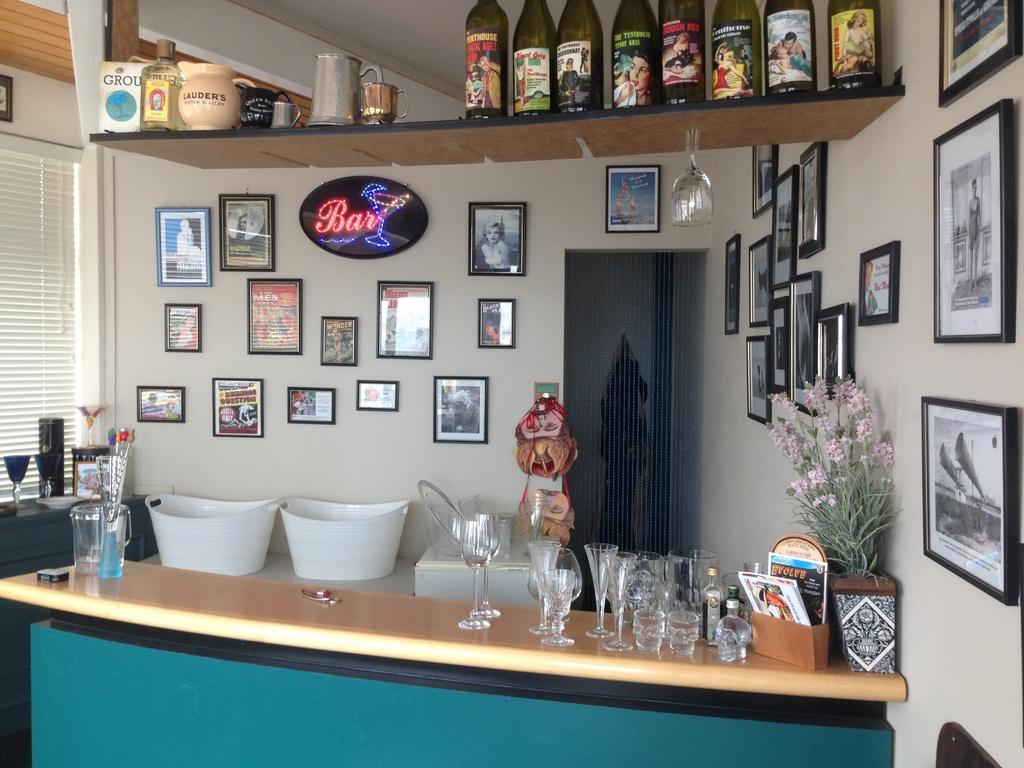Provide a one-sentence caption for the provided image. A neon sign that say's bar on it hangs on a wall with other pictures. 